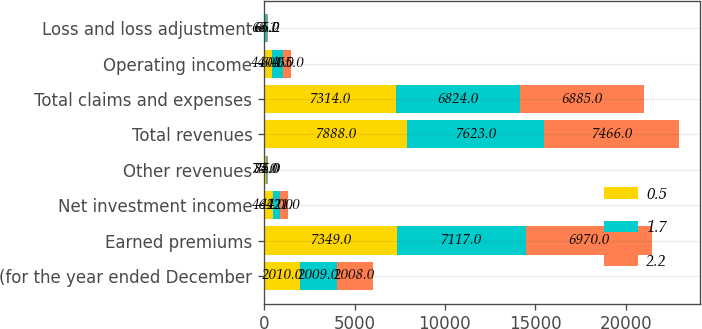Convert chart to OTSL. <chart><loc_0><loc_0><loc_500><loc_500><stacked_bar_chart><ecel><fcel>(for the year ended December<fcel>Earned premiums<fcel>Net investment income<fcel>Other revenues<fcel>Total revenues<fcel>Total claims and expenses<fcel>Operating income<fcel>Loss and loss adjustment<nl><fcel>0.5<fcel>2010<fcel>7349<fcel>464<fcel>75<fcel>7888<fcel>7314<fcel>440<fcel>68.1<nl><fcel>1.7<fcel>2009<fcel>7117<fcel>422<fcel>84<fcel>7623<fcel>6824<fcel>601<fcel>65<nl><fcel>2.2<fcel>2008<fcel>6970<fcel>421<fcel>75<fcel>7466<fcel>6885<fcel>465<fcel>66.2<nl></chart> 